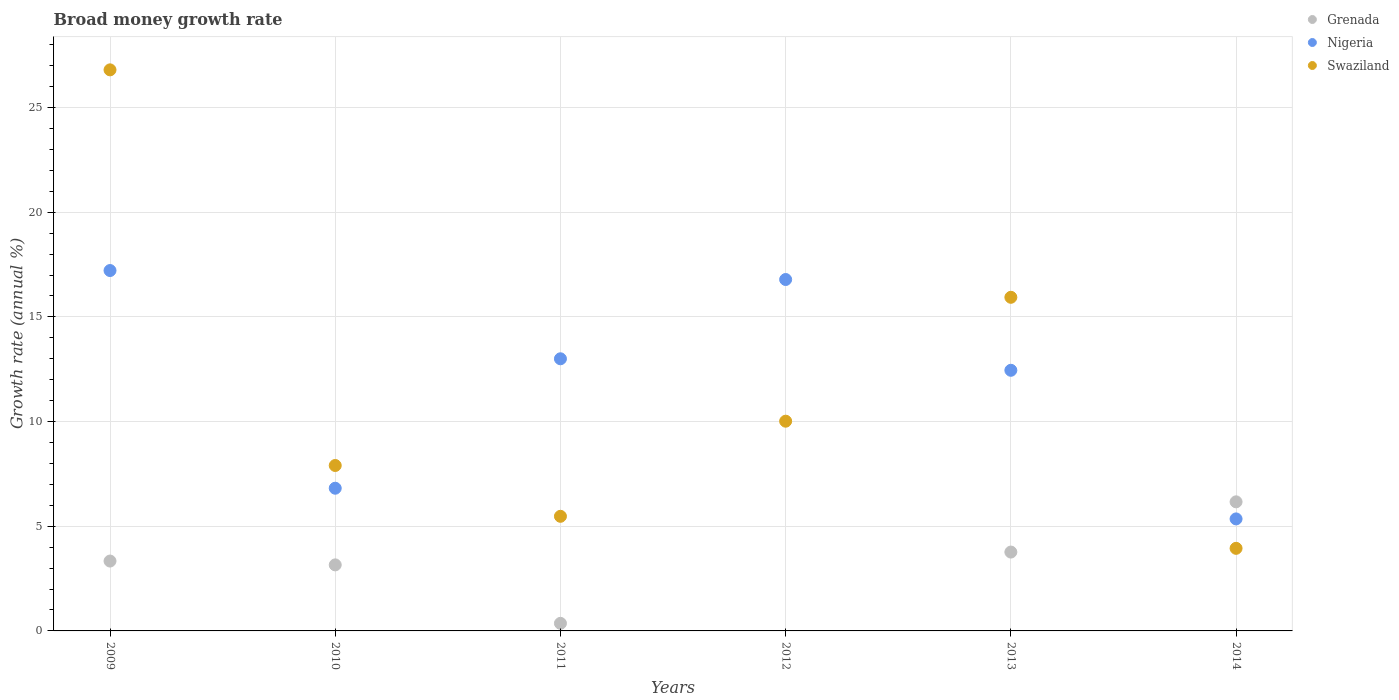What is the growth rate in Nigeria in 2012?
Ensure brevity in your answer.  16.79. Across all years, what is the maximum growth rate in Swaziland?
Your answer should be very brief. 26.8. Across all years, what is the minimum growth rate in Grenada?
Ensure brevity in your answer.  0. What is the total growth rate in Nigeria in the graph?
Your response must be concise. 71.62. What is the difference between the growth rate in Swaziland in 2009 and that in 2013?
Keep it short and to the point. 10.86. What is the difference between the growth rate in Swaziland in 2014 and the growth rate in Nigeria in 2012?
Offer a terse response. -12.84. What is the average growth rate in Nigeria per year?
Provide a short and direct response. 11.94. In the year 2014, what is the difference between the growth rate in Swaziland and growth rate in Nigeria?
Offer a very short reply. -1.41. In how many years, is the growth rate in Swaziland greater than 27 %?
Offer a terse response. 0. What is the ratio of the growth rate in Nigeria in 2009 to that in 2013?
Your response must be concise. 1.38. What is the difference between the highest and the second highest growth rate in Nigeria?
Your answer should be compact. 0.43. What is the difference between the highest and the lowest growth rate in Grenada?
Give a very brief answer. 6.17. Does the growth rate in Nigeria monotonically increase over the years?
Your response must be concise. No. Is the growth rate in Grenada strictly greater than the growth rate in Nigeria over the years?
Provide a succinct answer. No. How many dotlines are there?
Your response must be concise. 3. How many years are there in the graph?
Offer a very short reply. 6. What is the difference between two consecutive major ticks on the Y-axis?
Make the answer very short. 5. Are the values on the major ticks of Y-axis written in scientific E-notation?
Make the answer very short. No. Does the graph contain grids?
Keep it short and to the point. Yes. Where does the legend appear in the graph?
Your answer should be very brief. Top right. What is the title of the graph?
Offer a terse response. Broad money growth rate. What is the label or title of the Y-axis?
Ensure brevity in your answer.  Growth rate (annual %). What is the Growth rate (annual %) in Grenada in 2009?
Give a very brief answer. 3.34. What is the Growth rate (annual %) of Nigeria in 2009?
Keep it short and to the point. 17.21. What is the Growth rate (annual %) in Swaziland in 2009?
Make the answer very short. 26.8. What is the Growth rate (annual %) in Grenada in 2010?
Ensure brevity in your answer.  3.15. What is the Growth rate (annual %) in Nigeria in 2010?
Your response must be concise. 6.82. What is the Growth rate (annual %) of Swaziland in 2010?
Your answer should be compact. 7.9. What is the Growth rate (annual %) in Grenada in 2011?
Your answer should be very brief. 0.36. What is the Growth rate (annual %) in Nigeria in 2011?
Give a very brief answer. 13. What is the Growth rate (annual %) of Swaziland in 2011?
Your answer should be compact. 5.48. What is the Growth rate (annual %) in Grenada in 2012?
Offer a very short reply. 0. What is the Growth rate (annual %) of Nigeria in 2012?
Provide a succinct answer. 16.79. What is the Growth rate (annual %) of Swaziland in 2012?
Keep it short and to the point. 10.02. What is the Growth rate (annual %) of Grenada in 2013?
Provide a short and direct response. 3.77. What is the Growth rate (annual %) of Nigeria in 2013?
Ensure brevity in your answer.  12.45. What is the Growth rate (annual %) of Swaziland in 2013?
Give a very brief answer. 15.94. What is the Growth rate (annual %) in Grenada in 2014?
Your answer should be compact. 6.17. What is the Growth rate (annual %) of Nigeria in 2014?
Provide a short and direct response. 5.35. What is the Growth rate (annual %) in Swaziland in 2014?
Your answer should be very brief. 3.94. Across all years, what is the maximum Growth rate (annual %) in Grenada?
Make the answer very short. 6.17. Across all years, what is the maximum Growth rate (annual %) of Nigeria?
Ensure brevity in your answer.  17.21. Across all years, what is the maximum Growth rate (annual %) of Swaziland?
Your response must be concise. 26.8. Across all years, what is the minimum Growth rate (annual %) of Nigeria?
Your answer should be compact. 5.35. Across all years, what is the minimum Growth rate (annual %) of Swaziland?
Your answer should be very brief. 3.94. What is the total Growth rate (annual %) of Grenada in the graph?
Give a very brief answer. 16.79. What is the total Growth rate (annual %) in Nigeria in the graph?
Provide a succinct answer. 71.62. What is the total Growth rate (annual %) of Swaziland in the graph?
Offer a very short reply. 70.08. What is the difference between the Growth rate (annual %) of Grenada in 2009 and that in 2010?
Make the answer very short. 0.18. What is the difference between the Growth rate (annual %) of Nigeria in 2009 and that in 2010?
Provide a short and direct response. 10.4. What is the difference between the Growth rate (annual %) of Swaziland in 2009 and that in 2010?
Provide a short and direct response. 18.9. What is the difference between the Growth rate (annual %) in Grenada in 2009 and that in 2011?
Make the answer very short. 2.98. What is the difference between the Growth rate (annual %) of Nigeria in 2009 and that in 2011?
Your answer should be compact. 4.22. What is the difference between the Growth rate (annual %) in Swaziland in 2009 and that in 2011?
Make the answer very short. 21.33. What is the difference between the Growth rate (annual %) of Nigeria in 2009 and that in 2012?
Provide a short and direct response. 0.43. What is the difference between the Growth rate (annual %) in Swaziland in 2009 and that in 2012?
Your response must be concise. 16.78. What is the difference between the Growth rate (annual %) of Grenada in 2009 and that in 2013?
Keep it short and to the point. -0.43. What is the difference between the Growth rate (annual %) in Nigeria in 2009 and that in 2013?
Your answer should be very brief. 4.76. What is the difference between the Growth rate (annual %) of Swaziland in 2009 and that in 2013?
Offer a very short reply. 10.86. What is the difference between the Growth rate (annual %) of Grenada in 2009 and that in 2014?
Offer a very short reply. -2.83. What is the difference between the Growth rate (annual %) in Nigeria in 2009 and that in 2014?
Provide a short and direct response. 11.86. What is the difference between the Growth rate (annual %) in Swaziland in 2009 and that in 2014?
Your answer should be very brief. 22.86. What is the difference between the Growth rate (annual %) of Grenada in 2010 and that in 2011?
Your answer should be very brief. 2.79. What is the difference between the Growth rate (annual %) of Nigeria in 2010 and that in 2011?
Your answer should be very brief. -6.18. What is the difference between the Growth rate (annual %) in Swaziland in 2010 and that in 2011?
Give a very brief answer. 2.43. What is the difference between the Growth rate (annual %) of Nigeria in 2010 and that in 2012?
Your answer should be compact. -9.97. What is the difference between the Growth rate (annual %) of Swaziland in 2010 and that in 2012?
Keep it short and to the point. -2.12. What is the difference between the Growth rate (annual %) in Grenada in 2010 and that in 2013?
Give a very brief answer. -0.61. What is the difference between the Growth rate (annual %) in Nigeria in 2010 and that in 2013?
Your answer should be compact. -5.63. What is the difference between the Growth rate (annual %) in Swaziland in 2010 and that in 2013?
Offer a terse response. -8.03. What is the difference between the Growth rate (annual %) of Grenada in 2010 and that in 2014?
Your answer should be very brief. -3.01. What is the difference between the Growth rate (annual %) of Nigeria in 2010 and that in 2014?
Make the answer very short. 1.47. What is the difference between the Growth rate (annual %) in Swaziland in 2010 and that in 2014?
Make the answer very short. 3.96. What is the difference between the Growth rate (annual %) of Nigeria in 2011 and that in 2012?
Ensure brevity in your answer.  -3.79. What is the difference between the Growth rate (annual %) of Swaziland in 2011 and that in 2012?
Provide a succinct answer. -4.54. What is the difference between the Growth rate (annual %) in Grenada in 2011 and that in 2013?
Make the answer very short. -3.4. What is the difference between the Growth rate (annual %) of Nigeria in 2011 and that in 2013?
Your answer should be compact. 0.55. What is the difference between the Growth rate (annual %) of Swaziland in 2011 and that in 2013?
Give a very brief answer. -10.46. What is the difference between the Growth rate (annual %) of Grenada in 2011 and that in 2014?
Provide a succinct answer. -5.8. What is the difference between the Growth rate (annual %) of Nigeria in 2011 and that in 2014?
Provide a short and direct response. 7.65. What is the difference between the Growth rate (annual %) of Swaziland in 2011 and that in 2014?
Provide a short and direct response. 1.53. What is the difference between the Growth rate (annual %) of Nigeria in 2012 and that in 2013?
Provide a short and direct response. 4.34. What is the difference between the Growth rate (annual %) in Swaziland in 2012 and that in 2013?
Your response must be concise. -5.92. What is the difference between the Growth rate (annual %) of Nigeria in 2012 and that in 2014?
Keep it short and to the point. 11.44. What is the difference between the Growth rate (annual %) of Swaziland in 2012 and that in 2014?
Your answer should be compact. 6.07. What is the difference between the Growth rate (annual %) in Grenada in 2013 and that in 2014?
Provide a short and direct response. -2.4. What is the difference between the Growth rate (annual %) in Nigeria in 2013 and that in 2014?
Your answer should be compact. 7.1. What is the difference between the Growth rate (annual %) of Swaziland in 2013 and that in 2014?
Your answer should be compact. 11.99. What is the difference between the Growth rate (annual %) in Grenada in 2009 and the Growth rate (annual %) in Nigeria in 2010?
Your answer should be compact. -3.48. What is the difference between the Growth rate (annual %) in Grenada in 2009 and the Growth rate (annual %) in Swaziland in 2010?
Make the answer very short. -4.56. What is the difference between the Growth rate (annual %) in Nigeria in 2009 and the Growth rate (annual %) in Swaziland in 2010?
Your answer should be compact. 9.31. What is the difference between the Growth rate (annual %) of Grenada in 2009 and the Growth rate (annual %) of Nigeria in 2011?
Your answer should be very brief. -9.66. What is the difference between the Growth rate (annual %) in Grenada in 2009 and the Growth rate (annual %) in Swaziland in 2011?
Your response must be concise. -2.14. What is the difference between the Growth rate (annual %) in Nigeria in 2009 and the Growth rate (annual %) in Swaziland in 2011?
Provide a succinct answer. 11.74. What is the difference between the Growth rate (annual %) in Grenada in 2009 and the Growth rate (annual %) in Nigeria in 2012?
Give a very brief answer. -13.45. What is the difference between the Growth rate (annual %) in Grenada in 2009 and the Growth rate (annual %) in Swaziland in 2012?
Provide a short and direct response. -6.68. What is the difference between the Growth rate (annual %) of Nigeria in 2009 and the Growth rate (annual %) of Swaziland in 2012?
Provide a succinct answer. 7.2. What is the difference between the Growth rate (annual %) of Grenada in 2009 and the Growth rate (annual %) of Nigeria in 2013?
Your answer should be very brief. -9.11. What is the difference between the Growth rate (annual %) in Grenada in 2009 and the Growth rate (annual %) in Swaziland in 2013?
Keep it short and to the point. -12.6. What is the difference between the Growth rate (annual %) in Nigeria in 2009 and the Growth rate (annual %) in Swaziland in 2013?
Make the answer very short. 1.28. What is the difference between the Growth rate (annual %) in Grenada in 2009 and the Growth rate (annual %) in Nigeria in 2014?
Your response must be concise. -2.01. What is the difference between the Growth rate (annual %) of Grenada in 2009 and the Growth rate (annual %) of Swaziland in 2014?
Provide a short and direct response. -0.61. What is the difference between the Growth rate (annual %) in Nigeria in 2009 and the Growth rate (annual %) in Swaziland in 2014?
Your response must be concise. 13.27. What is the difference between the Growth rate (annual %) in Grenada in 2010 and the Growth rate (annual %) in Nigeria in 2011?
Make the answer very short. -9.84. What is the difference between the Growth rate (annual %) of Grenada in 2010 and the Growth rate (annual %) of Swaziland in 2011?
Give a very brief answer. -2.32. What is the difference between the Growth rate (annual %) in Nigeria in 2010 and the Growth rate (annual %) in Swaziland in 2011?
Your response must be concise. 1.34. What is the difference between the Growth rate (annual %) of Grenada in 2010 and the Growth rate (annual %) of Nigeria in 2012?
Offer a terse response. -13.63. What is the difference between the Growth rate (annual %) in Grenada in 2010 and the Growth rate (annual %) in Swaziland in 2012?
Keep it short and to the point. -6.86. What is the difference between the Growth rate (annual %) in Nigeria in 2010 and the Growth rate (annual %) in Swaziland in 2012?
Keep it short and to the point. -3.2. What is the difference between the Growth rate (annual %) in Grenada in 2010 and the Growth rate (annual %) in Nigeria in 2013?
Make the answer very short. -9.29. What is the difference between the Growth rate (annual %) in Grenada in 2010 and the Growth rate (annual %) in Swaziland in 2013?
Keep it short and to the point. -12.78. What is the difference between the Growth rate (annual %) of Nigeria in 2010 and the Growth rate (annual %) of Swaziland in 2013?
Offer a very short reply. -9.12. What is the difference between the Growth rate (annual %) in Grenada in 2010 and the Growth rate (annual %) in Nigeria in 2014?
Your response must be concise. -2.2. What is the difference between the Growth rate (annual %) in Grenada in 2010 and the Growth rate (annual %) in Swaziland in 2014?
Your answer should be very brief. -0.79. What is the difference between the Growth rate (annual %) in Nigeria in 2010 and the Growth rate (annual %) in Swaziland in 2014?
Give a very brief answer. 2.87. What is the difference between the Growth rate (annual %) in Grenada in 2011 and the Growth rate (annual %) in Nigeria in 2012?
Offer a terse response. -16.42. What is the difference between the Growth rate (annual %) of Grenada in 2011 and the Growth rate (annual %) of Swaziland in 2012?
Offer a very short reply. -9.66. What is the difference between the Growth rate (annual %) in Nigeria in 2011 and the Growth rate (annual %) in Swaziland in 2012?
Your answer should be very brief. 2.98. What is the difference between the Growth rate (annual %) of Grenada in 2011 and the Growth rate (annual %) of Nigeria in 2013?
Offer a very short reply. -12.09. What is the difference between the Growth rate (annual %) in Grenada in 2011 and the Growth rate (annual %) in Swaziland in 2013?
Your response must be concise. -15.57. What is the difference between the Growth rate (annual %) in Nigeria in 2011 and the Growth rate (annual %) in Swaziland in 2013?
Your answer should be compact. -2.94. What is the difference between the Growth rate (annual %) of Grenada in 2011 and the Growth rate (annual %) of Nigeria in 2014?
Provide a succinct answer. -4.99. What is the difference between the Growth rate (annual %) of Grenada in 2011 and the Growth rate (annual %) of Swaziland in 2014?
Offer a very short reply. -3.58. What is the difference between the Growth rate (annual %) in Nigeria in 2011 and the Growth rate (annual %) in Swaziland in 2014?
Ensure brevity in your answer.  9.05. What is the difference between the Growth rate (annual %) in Nigeria in 2012 and the Growth rate (annual %) in Swaziland in 2013?
Provide a succinct answer. 0.85. What is the difference between the Growth rate (annual %) in Nigeria in 2012 and the Growth rate (annual %) in Swaziland in 2014?
Provide a short and direct response. 12.84. What is the difference between the Growth rate (annual %) of Grenada in 2013 and the Growth rate (annual %) of Nigeria in 2014?
Your answer should be very brief. -1.58. What is the difference between the Growth rate (annual %) in Grenada in 2013 and the Growth rate (annual %) in Swaziland in 2014?
Offer a terse response. -0.18. What is the difference between the Growth rate (annual %) of Nigeria in 2013 and the Growth rate (annual %) of Swaziland in 2014?
Offer a terse response. 8.5. What is the average Growth rate (annual %) in Grenada per year?
Keep it short and to the point. 2.8. What is the average Growth rate (annual %) of Nigeria per year?
Offer a very short reply. 11.94. What is the average Growth rate (annual %) of Swaziland per year?
Make the answer very short. 11.68. In the year 2009, what is the difference between the Growth rate (annual %) of Grenada and Growth rate (annual %) of Nigeria?
Keep it short and to the point. -13.88. In the year 2009, what is the difference between the Growth rate (annual %) in Grenada and Growth rate (annual %) in Swaziland?
Ensure brevity in your answer.  -23.46. In the year 2009, what is the difference between the Growth rate (annual %) in Nigeria and Growth rate (annual %) in Swaziland?
Provide a short and direct response. -9.59. In the year 2010, what is the difference between the Growth rate (annual %) of Grenada and Growth rate (annual %) of Nigeria?
Offer a terse response. -3.66. In the year 2010, what is the difference between the Growth rate (annual %) of Grenada and Growth rate (annual %) of Swaziland?
Your response must be concise. -4.75. In the year 2010, what is the difference between the Growth rate (annual %) of Nigeria and Growth rate (annual %) of Swaziland?
Make the answer very short. -1.09. In the year 2011, what is the difference between the Growth rate (annual %) in Grenada and Growth rate (annual %) in Nigeria?
Provide a short and direct response. -12.64. In the year 2011, what is the difference between the Growth rate (annual %) of Grenada and Growth rate (annual %) of Swaziland?
Make the answer very short. -5.11. In the year 2011, what is the difference between the Growth rate (annual %) of Nigeria and Growth rate (annual %) of Swaziland?
Keep it short and to the point. 7.52. In the year 2012, what is the difference between the Growth rate (annual %) of Nigeria and Growth rate (annual %) of Swaziland?
Offer a terse response. 6.77. In the year 2013, what is the difference between the Growth rate (annual %) of Grenada and Growth rate (annual %) of Nigeria?
Your answer should be very brief. -8.68. In the year 2013, what is the difference between the Growth rate (annual %) of Grenada and Growth rate (annual %) of Swaziland?
Keep it short and to the point. -12.17. In the year 2013, what is the difference between the Growth rate (annual %) of Nigeria and Growth rate (annual %) of Swaziland?
Provide a short and direct response. -3.49. In the year 2014, what is the difference between the Growth rate (annual %) in Grenada and Growth rate (annual %) in Nigeria?
Your answer should be very brief. 0.82. In the year 2014, what is the difference between the Growth rate (annual %) of Grenada and Growth rate (annual %) of Swaziland?
Provide a short and direct response. 2.22. In the year 2014, what is the difference between the Growth rate (annual %) in Nigeria and Growth rate (annual %) in Swaziland?
Offer a very short reply. 1.41. What is the ratio of the Growth rate (annual %) in Grenada in 2009 to that in 2010?
Make the answer very short. 1.06. What is the ratio of the Growth rate (annual %) of Nigeria in 2009 to that in 2010?
Your answer should be very brief. 2.53. What is the ratio of the Growth rate (annual %) in Swaziland in 2009 to that in 2010?
Offer a terse response. 3.39. What is the ratio of the Growth rate (annual %) of Grenada in 2009 to that in 2011?
Provide a short and direct response. 9.22. What is the ratio of the Growth rate (annual %) of Nigeria in 2009 to that in 2011?
Ensure brevity in your answer.  1.32. What is the ratio of the Growth rate (annual %) of Swaziland in 2009 to that in 2011?
Offer a terse response. 4.89. What is the ratio of the Growth rate (annual %) in Nigeria in 2009 to that in 2012?
Offer a terse response. 1.03. What is the ratio of the Growth rate (annual %) of Swaziland in 2009 to that in 2012?
Offer a very short reply. 2.68. What is the ratio of the Growth rate (annual %) in Grenada in 2009 to that in 2013?
Ensure brevity in your answer.  0.89. What is the ratio of the Growth rate (annual %) in Nigeria in 2009 to that in 2013?
Ensure brevity in your answer.  1.38. What is the ratio of the Growth rate (annual %) of Swaziland in 2009 to that in 2013?
Your response must be concise. 1.68. What is the ratio of the Growth rate (annual %) of Grenada in 2009 to that in 2014?
Offer a terse response. 0.54. What is the ratio of the Growth rate (annual %) in Nigeria in 2009 to that in 2014?
Give a very brief answer. 3.22. What is the ratio of the Growth rate (annual %) in Swaziland in 2009 to that in 2014?
Provide a short and direct response. 6.79. What is the ratio of the Growth rate (annual %) of Grenada in 2010 to that in 2011?
Provide a short and direct response. 8.72. What is the ratio of the Growth rate (annual %) in Nigeria in 2010 to that in 2011?
Your answer should be compact. 0.52. What is the ratio of the Growth rate (annual %) of Swaziland in 2010 to that in 2011?
Provide a short and direct response. 1.44. What is the ratio of the Growth rate (annual %) of Nigeria in 2010 to that in 2012?
Provide a succinct answer. 0.41. What is the ratio of the Growth rate (annual %) of Swaziland in 2010 to that in 2012?
Offer a very short reply. 0.79. What is the ratio of the Growth rate (annual %) in Grenada in 2010 to that in 2013?
Your answer should be very brief. 0.84. What is the ratio of the Growth rate (annual %) of Nigeria in 2010 to that in 2013?
Offer a very short reply. 0.55. What is the ratio of the Growth rate (annual %) in Swaziland in 2010 to that in 2013?
Your answer should be very brief. 0.5. What is the ratio of the Growth rate (annual %) of Grenada in 2010 to that in 2014?
Provide a short and direct response. 0.51. What is the ratio of the Growth rate (annual %) of Nigeria in 2010 to that in 2014?
Keep it short and to the point. 1.27. What is the ratio of the Growth rate (annual %) of Swaziland in 2010 to that in 2014?
Provide a succinct answer. 2. What is the ratio of the Growth rate (annual %) in Nigeria in 2011 to that in 2012?
Provide a succinct answer. 0.77. What is the ratio of the Growth rate (annual %) of Swaziland in 2011 to that in 2012?
Provide a short and direct response. 0.55. What is the ratio of the Growth rate (annual %) in Grenada in 2011 to that in 2013?
Ensure brevity in your answer.  0.1. What is the ratio of the Growth rate (annual %) in Nigeria in 2011 to that in 2013?
Provide a succinct answer. 1.04. What is the ratio of the Growth rate (annual %) in Swaziland in 2011 to that in 2013?
Your response must be concise. 0.34. What is the ratio of the Growth rate (annual %) of Grenada in 2011 to that in 2014?
Provide a succinct answer. 0.06. What is the ratio of the Growth rate (annual %) of Nigeria in 2011 to that in 2014?
Your answer should be compact. 2.43. What is the ratio of the Growth rate (annual %) of Swaziland in 2011 to that in 2014?
Offer a terse response. 1.39. What is the ratio of the Growth rate (annual %) of Nigeria in 2012 to that in 2013?
Provide a succinct answer. 1.35. What is the ratio of the Growth rate (annual %) in Swaziland in 2012 to that in 2013?
Give a very brief answer. 0.63. What is the ratio of the Growth rate (annual %) in Nigeria in 2012 to that in 2014?
Make the answer very short. 3.14. What is the ratio of the Growth rate (annual %) in Swaziland in 2012 to that in 2014?
Provide a short and direct response. 2.54. What is the ratio of the Growth rate (annual %) of Grenada in 2013 to that in 2014?
Provide a short and direct response. 0.61. What is the ratio of the Growth rate (annual %) in Nigeria in 2013 to that in 2014?
Ensure brevity in your answer.  2.33. What is the ratio of the Growth rate (annual %) in Swaziland in 2013 to that in 2014?
Your answer should be very brief. 4.04. What is the difference between the highest and the second highest Growth rate (annual %) in Grenada?
Offer a terse response. 2.4. What is the difference between the highest and the second highest Growth rate (annual %) of Nigeria?
Offer a very short reply. 0.43. What is the difference between the highest and the second highest Growth rate (annual %) of Swaziland?
Your response must be concise. 10.86. What is the difference between the highest and the lowest Growth rate (annual %) of Grenada?
Ensure brevity in your answer.  6.17. What is the difference between the highest and the lowest Growth rate (annual %) in Nigeria?
Offer a very short reply. 11.86. What is the difference between the highest and the lowest Growth rate (annual %) of Swaziland?
Your response must be concise. 22.86. 